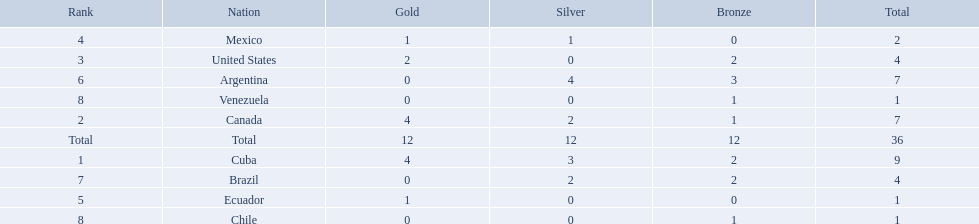Which nations won a gold medal in canoeing in the 2011 pan american games? Cuba, Canada, United States, Mexico, Ecuador. Which of these did not win any silver medals? United States. Which nations competed in the 2011 pan american games? Cuba, Canada, United States, Mexico, Ecuador, Argentina, Brazil, Chile, Venezuela. Of these nations which ones won gold? Cuba, Canada, United States, Mexico, Ecuador. Which nation of the ones that won gold did not win silver? United States. 